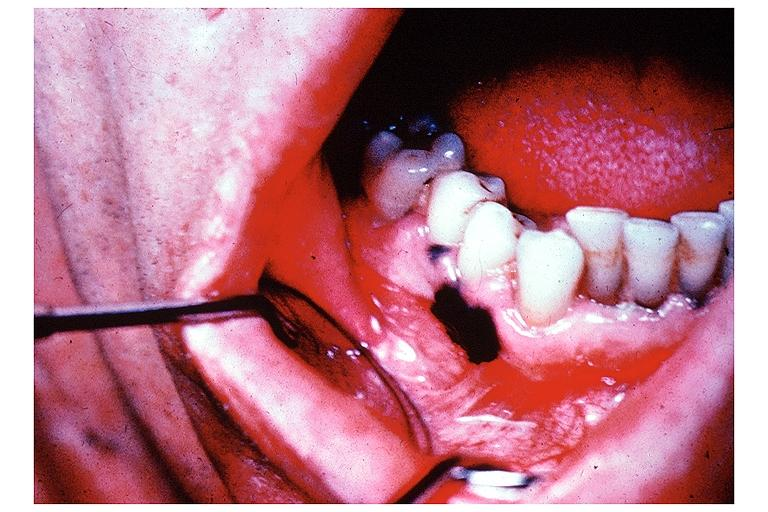where is this?
Answer the question using a single word or phrase. Oral 